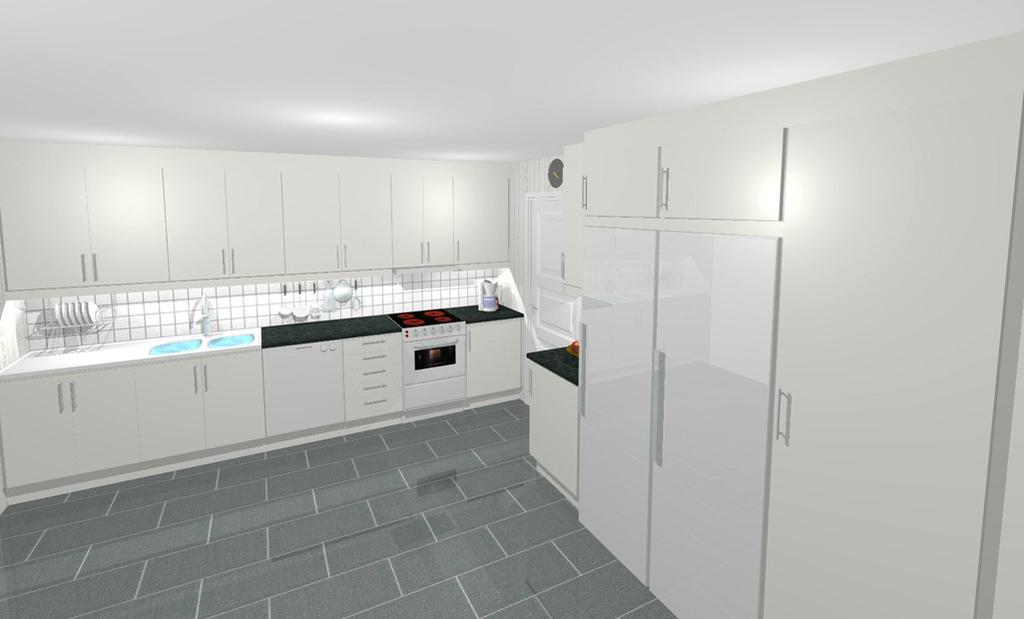What objects can be seen on the counter top in the image? There is a stove and an oven on the counter top in the image. What type of surface is visible in the image? The counter top is visible in the image. What type of storage is present in the image? There are cupboards in the image. What color is the wall behind the cupboards? The wall behind the cupboards is white. Can you tell me how many times the kettle has been used in the image? There is no kettle present in the image, so it is not possible to determine how many times it has been used. 